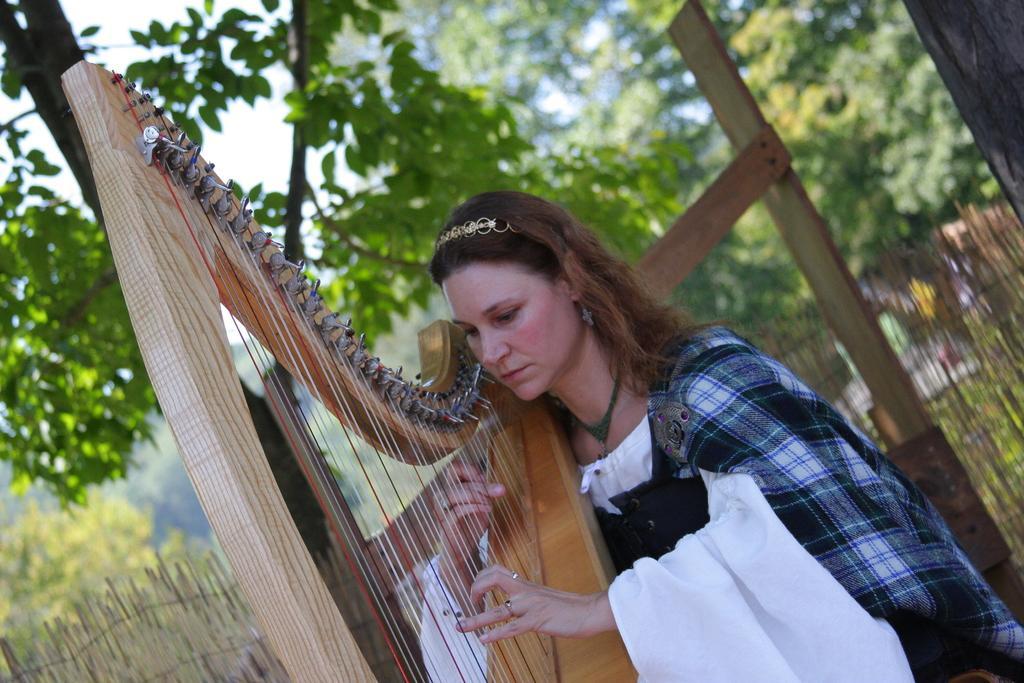Can you describe this image briefly? Here in this picture we can see a woman present over a place and we can see she is holding a musical instrument and playing it and behind her we can see plants and trees present on the ground. 